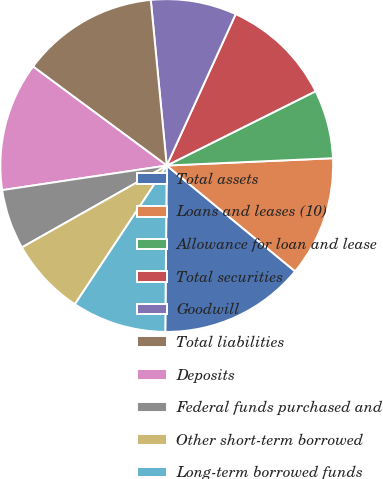Convert chart to OTSL. <chart><loc_0><loc_0><loc_500><loc_500><pie_chart><fcel>Total assets<fcel>Loans and leases (10)<fcel>Allowance for loan and lease<fcel>Total securities<fcel>Goodwill<fcel>Total liabilities<fcel>Deposits<fcel>Federal funds purchased and<fcel>Other short-term borrowed<fcel>Long-term borrowed funds<nl><fcel>14.17%<fcel>11.67%<fcel>6.67%<fcel>10.83%<fcel>8.33%<fcel>13.33%<fcel>12.5%<fcel>5.83%<fcel>7.5%<fcel>9.17%<nl></chart> 